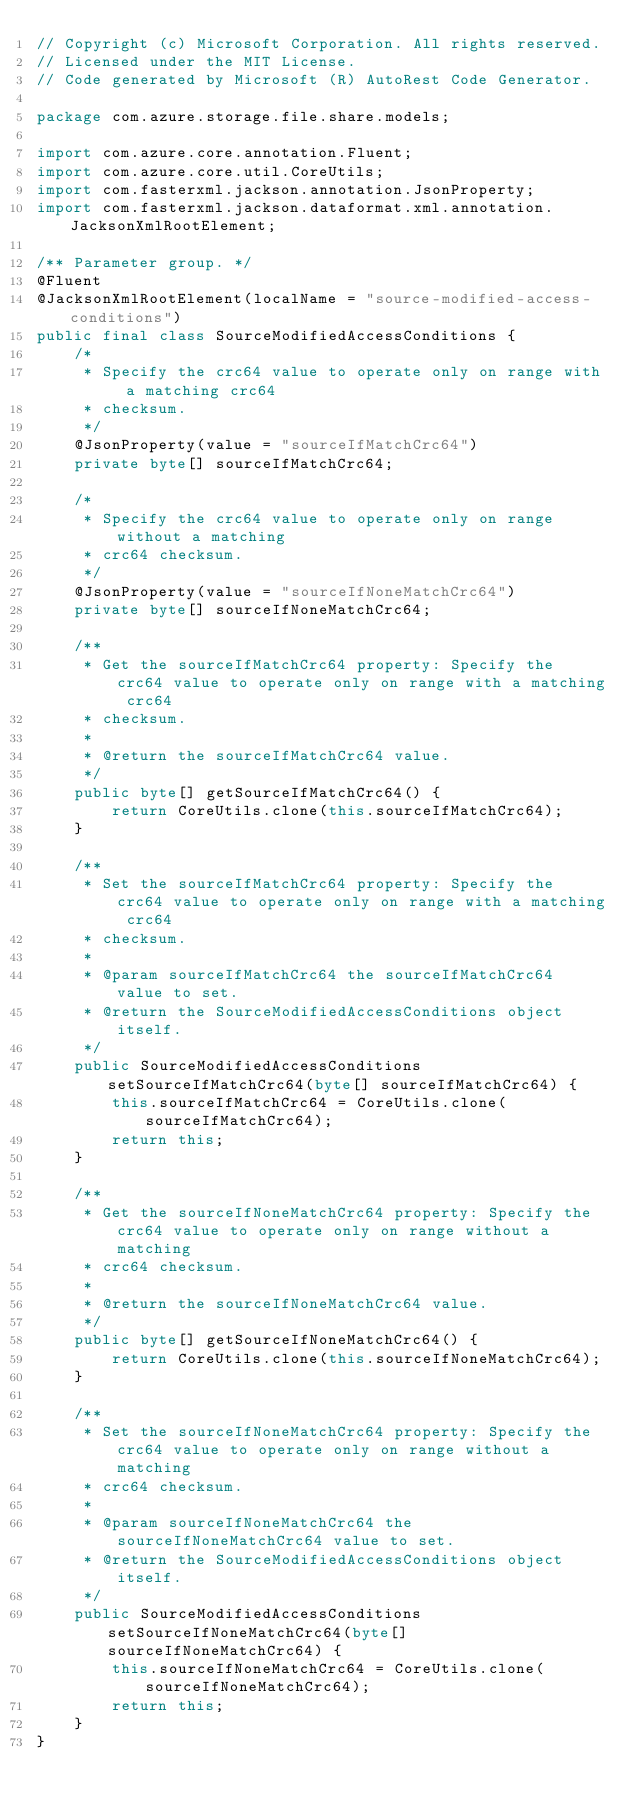Convert code to text. <code><loc_0><loc_0><loc_500><loc_500><_Java_>// Copyright (c) Microsoft Corporation. All rights reserved.
// Licensed under the MIT License.
// Code generated by Microsoft (R) AutoRest Code Generator.

package com.azure.storage.file.share.models;

import com.azure.core.annotation.Fluent;
import com.azure.core.util.CoreUtils;
import com.fasterxml.jackson.annotation.JsonProperty;
import com.fasterxml.jackson.dataformat.xml.annotation.JacksonXmlRootElement;

/** Parameter group. */
@Fluent
@JacksonXmlRootElement(localName = "source-modified-access-conditions")
public final class SourceModifiedAccessConditions {
    /*
     * Specify the crc64 value to operate only on range with a matching crc64
     * checksum.
     */
    @JsonProperty(value = "sourceIfMatchCrc64")
    private byte[] sourceIfMatchCrc64;

    /*
     * Specify the crc64 value to operate only on range without a matching
     * crc64 checksum.
     */
    @JsonProperty(value = "sourceIfNoneMatchCrc64")
    private byte[] sourceIfNoneMatchCrc64;

    /**
     * Get the sourceIfMatchCrc64 property: Specify the crc64 value to operate only on range with a matching crc64
     * checksum.
     *
     * @return the sourceIfMatchCrc64 value.
     */
    public byte[] getSourceIfMatchCrc64() {
        return CoreUtils.clone(this.sourceIfMatchCrc64);
    }

    /**
     * Set the sourceIfMatchCrc64 property: Specify the crc64 value to operate only on range with a matching crc64
     * checksum.
     *
     * @param sourceIfMatchCrc64 the sourceIfMatchCrc64 value to set.
     * @return the SourceModifiedAccessConditions object itself.
     */
    public SourceModifiedAccessConditions setSourceIfMatchCrc64(byte[] sourceIfMatchCrc64) {
        this.sourceIfMatchCrc64 = CoreUtils.clone(sourceIfMatchCrc64);
        return this;
    }

    /**
     * Get the sourceIfNoneMatchCrc64 property: Specify the crc64 value to operate only on range without a matching
     * crc64 checksum.
     *
     * @return the sourceIfNoneMatchCrc64 value.
     */
    public byte[] getSourceIfNoneMatchCrc64() {
        return CoreUtils.clone(this.sourceIfNoneMatchCrc64);
    }

    /**
     * Set the sourceIfNoneMatchCrc64 property: Specify the crc64 value to operate only on range without a matching
     * crc64 checksum.
     *
     * @param sourceIfNoneMatchCrc64 the sourceIfNoneMatchCrc64 value to set.
     * @return the SourceModifiedAccessConditions object itself.
     */
    public SourceModifiedAccessConditions setSourceIfNoneMatchCrc64(byte[] sourceIfNoneMatchCrc64) {
        this.sourceIfNoneMatchCrc64 = CoreUtils.clone(sourceIfNoneMatchCrc64);
        return this;
    }
}
</code> 